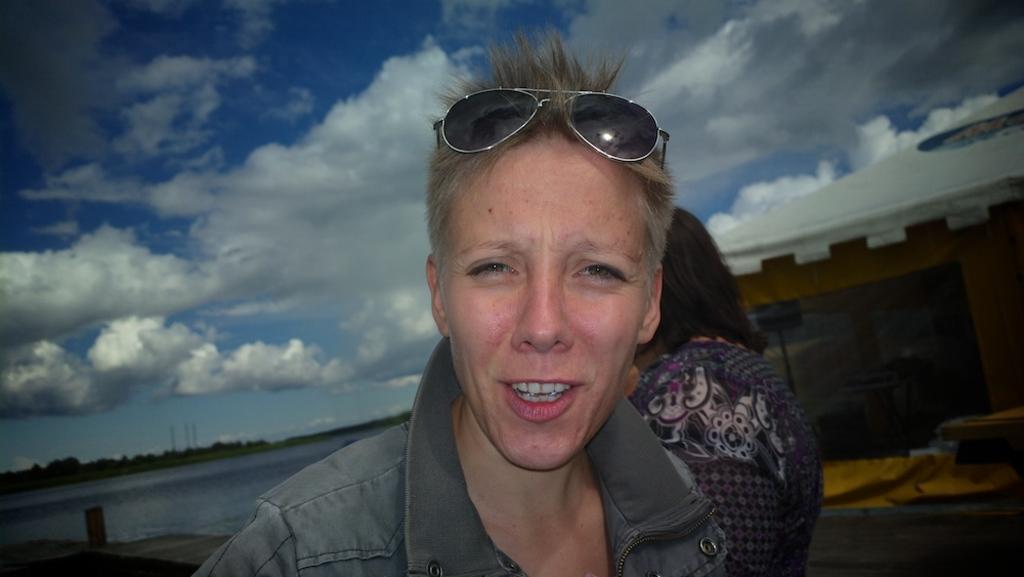Could you give a brief overview of what you see in this image? In this image we can see a person wearing jacket and cooling glasses standing and at the background of the image there is another person standing there is water, some trees and sunny sky. 